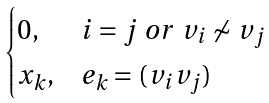Convert formula to latex. <formula><loc_0><loc_0><loc_500><loc_500>\begin{cases} 0 , & i = j \ o r \ v _ { i } \not \sim v _ { j } \\ x _ { k } , & e _ { k } = ( v _ { i } v _ { j } ) \end{cases}</formula> 